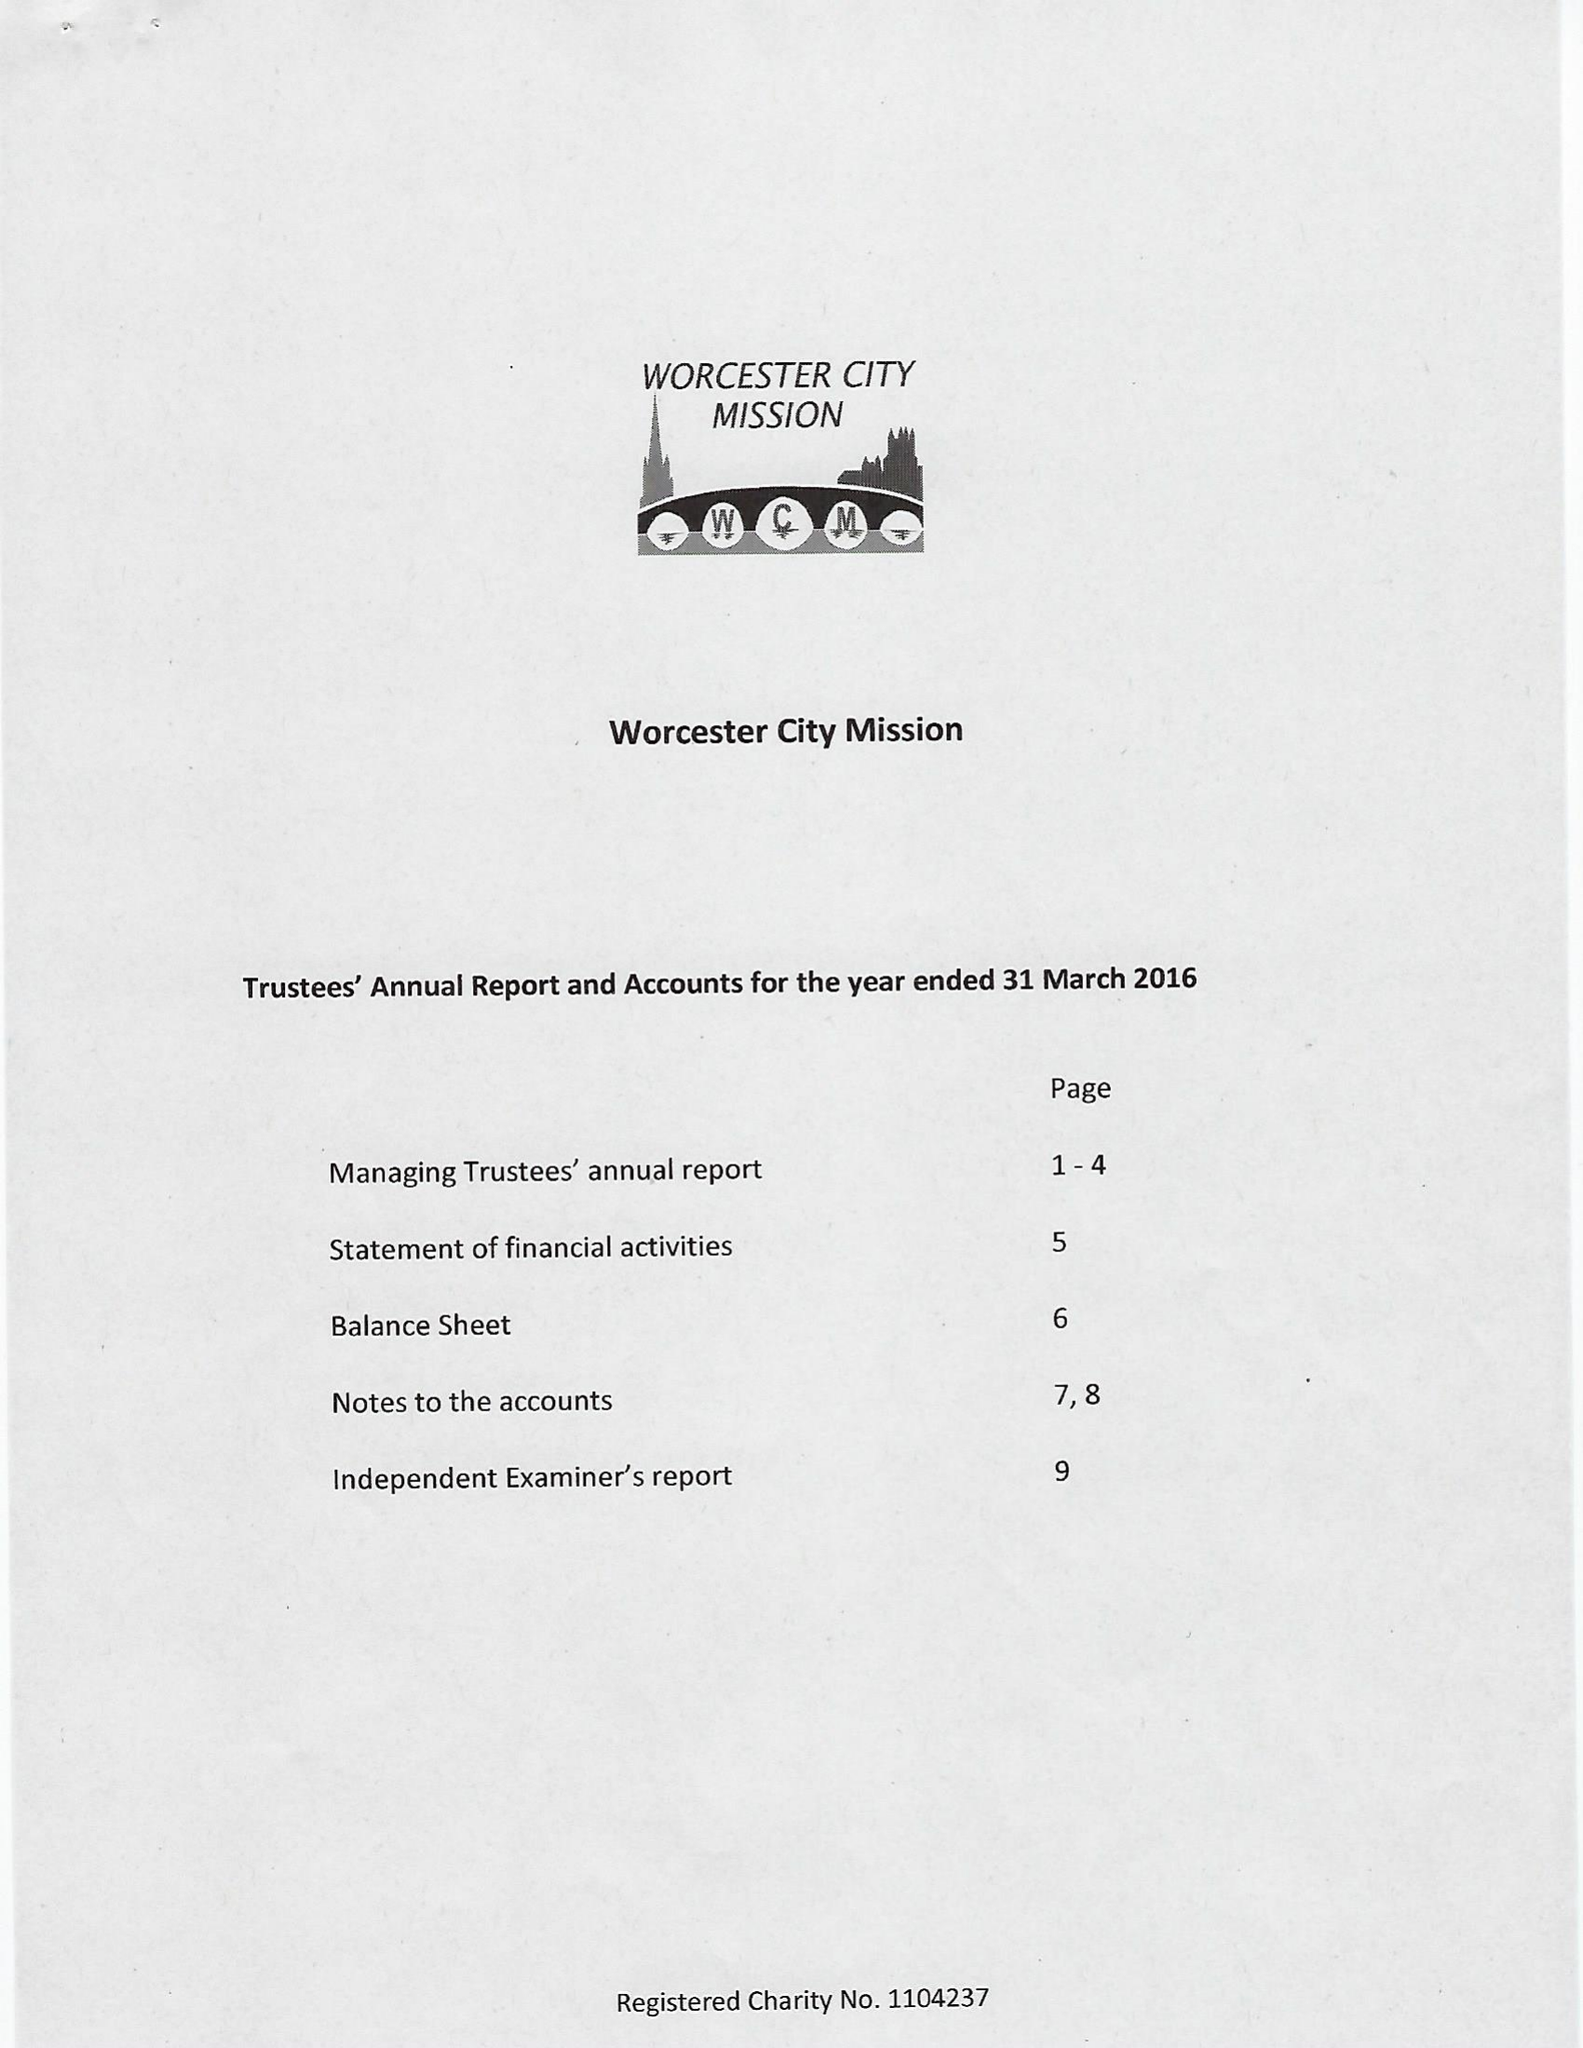What is the value for the spending_annually_in_british_pounds?
Answer the question using a single word or phrase. 5478.00 